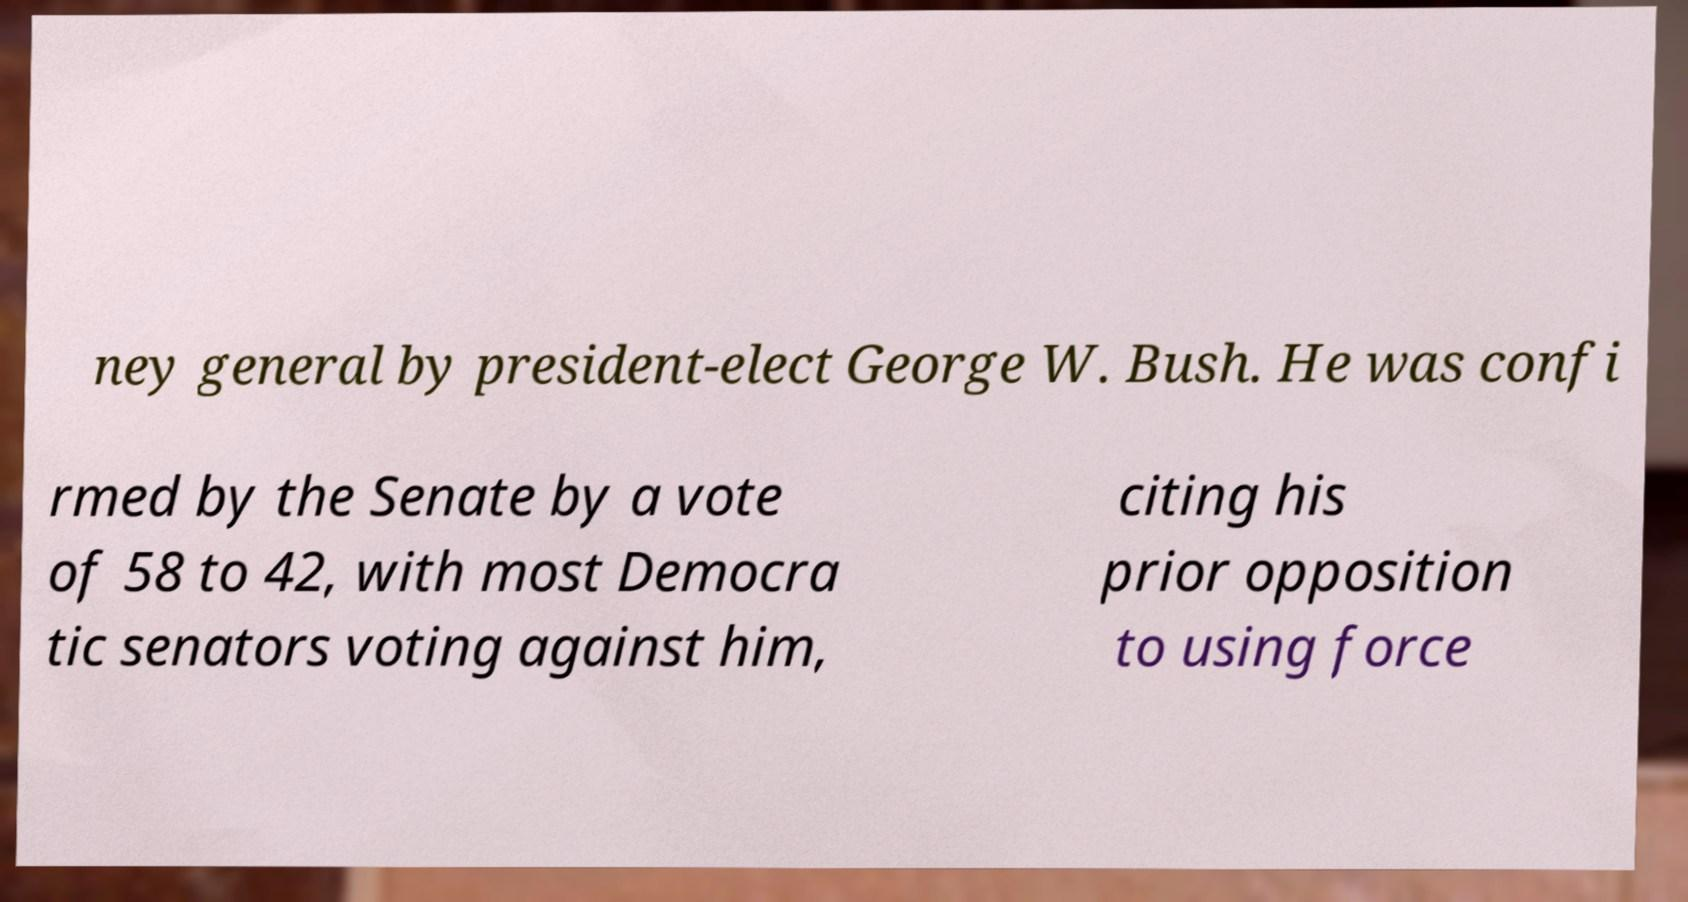Could you assist in decoding the text presented in this image and type it out clearly? ney general by president-elect George W. Bush. He was confi rmed by the Senate by a vote of 58 to 42, with most Democra tic senators voting against him, citing his prior opposition to using force 